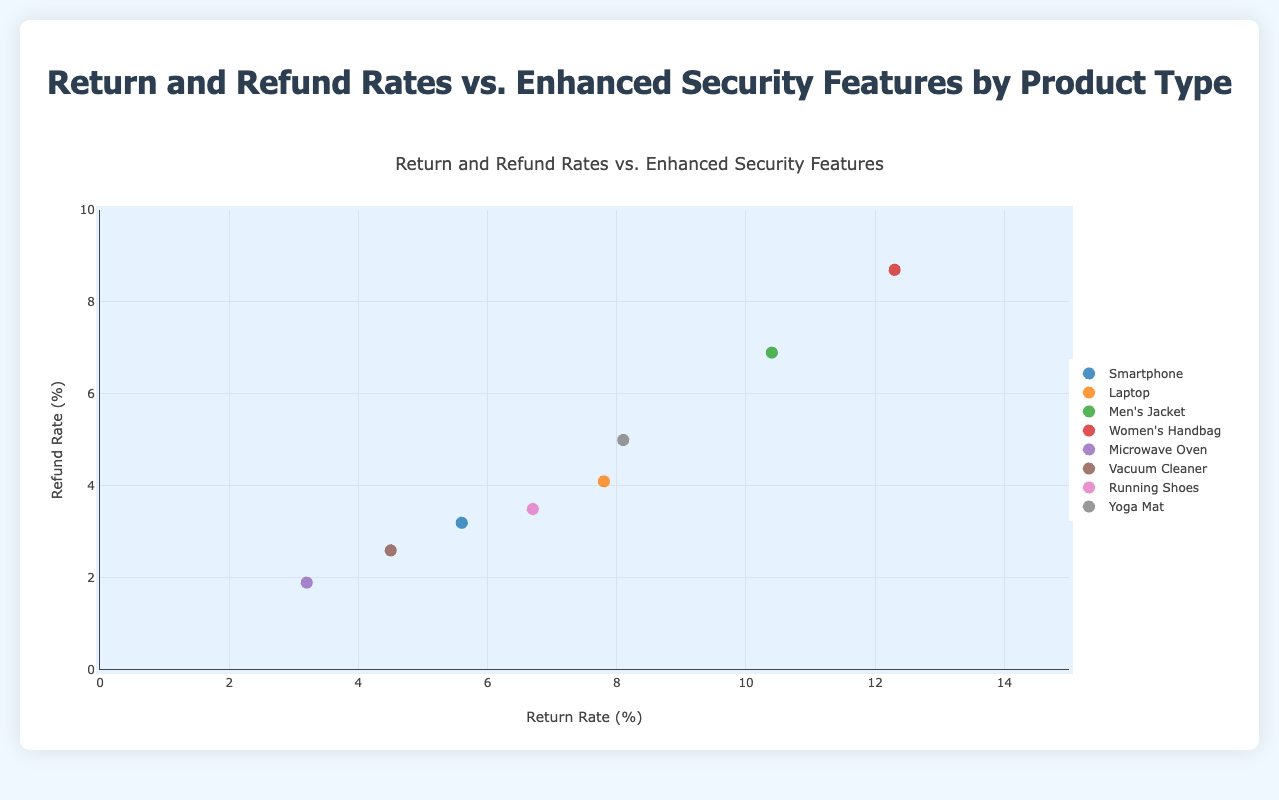What is the title of the figure? The title of the figure is located at the top and it reads "Return and Refund Rates vs. Enhanced Security Features by Product Type".
Answer: Return and Refund Rates vs. Enhanced Security Features by Product Type Which product has the highest return rate? The product with the highest return rate can be identified by looking at the x-axis (Return Rate) and finding the marker farthest to the right. This product is "Women's Handbag" with a return rate of 12.3%.
Answer: Women's Handbag What are the return and refund rates for the Microwave Oven? The Microwave Oven data point can be found by looking at its position on the plot. Its x-axis (return rate) is 3.2% and its y-axis (refund rate) is 1.9%.
Answer: 3.2% return rate, 1.9% refund rate Which product has the security feature "Forgery Prevention" and what are its return and refund rates? The product with the "Forgery Prevention" feature can be located by its text annotation. This product is "Running Shoes" with a return rate of 6.7% and a refund rate of 3.5%.
Answer: Running Shoes, 6.7% return rate, 3.5% refund rate What is the average refund rate for products in the "Fashion" category? There are two products in the "Fashion" category: "Men's Jacket" (6.9%) and "Women's Handbag" (8.7%). The average is calculated as (6.9 + 8.7) / 2 = 7.8%.
Answer: 7.8% How do the return and refund rates of "Electronics" compare to "Home Appliances"? "Electronics" has two products: "Smartphone" (5.6%, 3.2%) and "Laptop" (7.8%, 4.1%). "Home Appliances" has two products: "Microwave Oven" (3.2%, 1.9%) and "Vacuum Cleaner" (4.5%, 2.6%). Averaging them, Electronics return rate is (5.6 + 7.8) / 2 = 6.7%, and refund rate is (3.2 + 4.1) / 2 = 3.65%. Home Appliances return rate is (3.2 + 4.5) / 2 = 3.85%, and refund rate is (1.9 + 2.6) / 2 = 2.25%.
Answer: Electronics: 6.7% return rate, 3.65% refund rate; Home Appliances: 3.85% return rate, 2.25% refund rate Does the product with "Blockchain Authentication" have a higher refund rate than "Enhanced Encryption"? "Blockchain Authentication" is associated with "Laptop" (4.1% refund rate), and "Enhanced Encryption" is associated with "Smartphone" (3.2% refund rate). Comparing these values, "Laptop" has a higher refund rate.
Answer: Yes What is the return rate range for all products in the plot? To find the range, identify the minimum and maximum return rates on the x-axis. The minimum return rate is for "Microwave Oven" (3.2%) and the maximum is for "Women's Handbag" (12.3%). The range is 12.3 - 3.2 = 9.1%.
Answer: 3.2% to 12.3% Which product type tends to have higher return and refund rates, Electronics or Fashion? Compare the return and refund rates for products in both categories. Electronics: "Smartphone" (5.6%, 3.2%) and "Laptop" (7.8%, 4.1%). Fashion: "Men's Jacket" (10.4%, 6.9%) and "Women's Handbag" (12.3%, 8.7%). Both return and refund rates are higher in Fashion for all products.
Answer: Fashion 